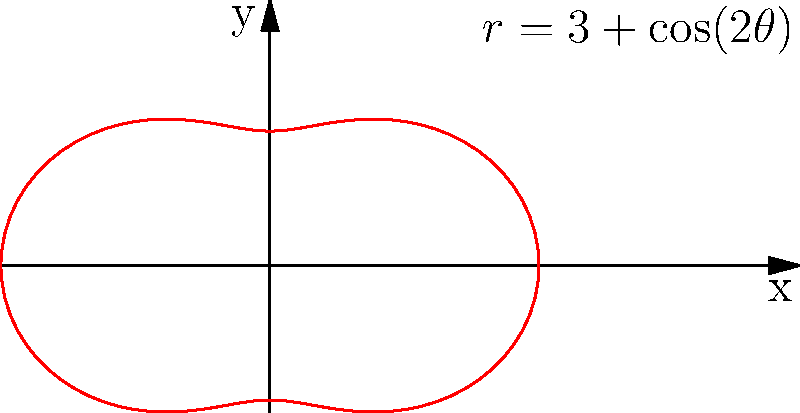As a union representative, you're organizing a picket line formation described by the polar equation $r=3+\cos(2\theta)$. Calculate the area enclosed by this formation to determine the space needed for the protest. Use the formula $A = \frac{1}{2}\int_0^{2\pi} r^2 d\theta$ to find the area. To calculate the area enclosed by the polar curve $r=3+\cos(2\theta)$, we'll follow these steps:

1) The formula for the area is $A = \frac{1}{2}\int_0^{2\pi} r^2 d\theta$

2) Substitute $r=3+\cos(2\theta)$ into the formula:
   $A = \frac{1}{2}\int_0^{2\pi} (3+\cos(2\theta))^2 d\theta$

3) Expand the squared term:
   $A = \frac{1}{2}\int_0^{2\pi} (9 + 6\cos(2\theta) + \cos^2(2\theta)) d\theta$

4) Use the identity $\cos^2(x) = \frac{1}{2}(1 + \cos(2x))$:
   $A = \frac{1}{2}\int_0^{2\pi} (9 + 6\cos(2\theta) + \frac{1}{2} + \frac{1}{2}\cos(4\theta)) d\theta$

5) Simplify:
   $A = \frac{1}{2}\int_0^{2\pi} (\frac{19}{2} + 6\cos(2\theta) + \frac{1}{2}\cos(4\theta)) d\theta$

6) Integrate term by term:
   $A = \frac{1}{2}[\frac{19}{2}\theta + 3\sin(2\theta) + \frac{1}{8}\sin(4\theta)]_0^{2\pi}$

7) Evaluate the definite integral:
   $A = \frac{1}{2}[(\frac{19}{2}(2\pi) + 3\sin(4\pi) + \frac{1}{8}\sin(8\pi)) - (0 + 0 + 0)]$

8) Simplify:
   $A = \frac{1}{2}(\frac{19\pi}{2}) = \frac{19\pi}{4}$

Therefore, the area enclosed by the picket line formation is $\frac{19\pi}{4}$ square units.
Answer: $\frac{19\pi}{4}$ square units 